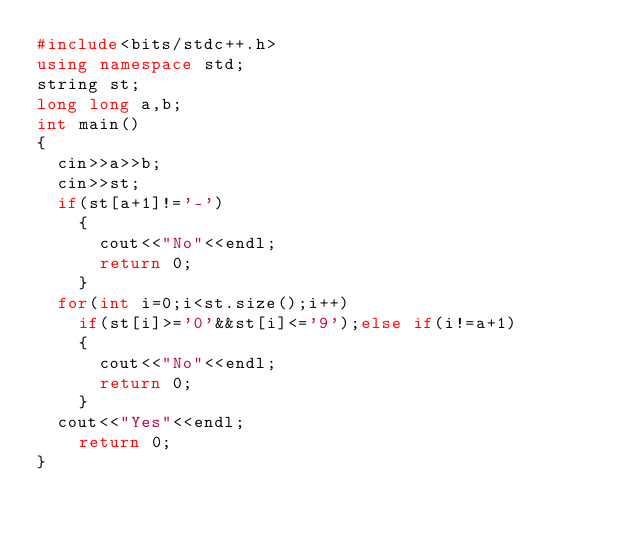Convert code to text. <code><loc_0><loc_0><loc_500><loc_500><_C++_>#include<bits/stdc++.h>
using namespace std;
string st;
long long a,b;
int main()
{
	cin>>a>>b;
	cin>>st;
	if(st[a+1]!='-')
	  {
	  	cout<<"No"<<endl;
	  	return 0;
	  }
	for(int i=0;i<st.size();i++)
		if(st[i]>='0'&&st[i]<='9');else if(i!=a+1)
		{
			cout<<"No"<<endl;
			return 0;
		}
	cout<<"Yes"<<endl;
    return 0;
}</code> 